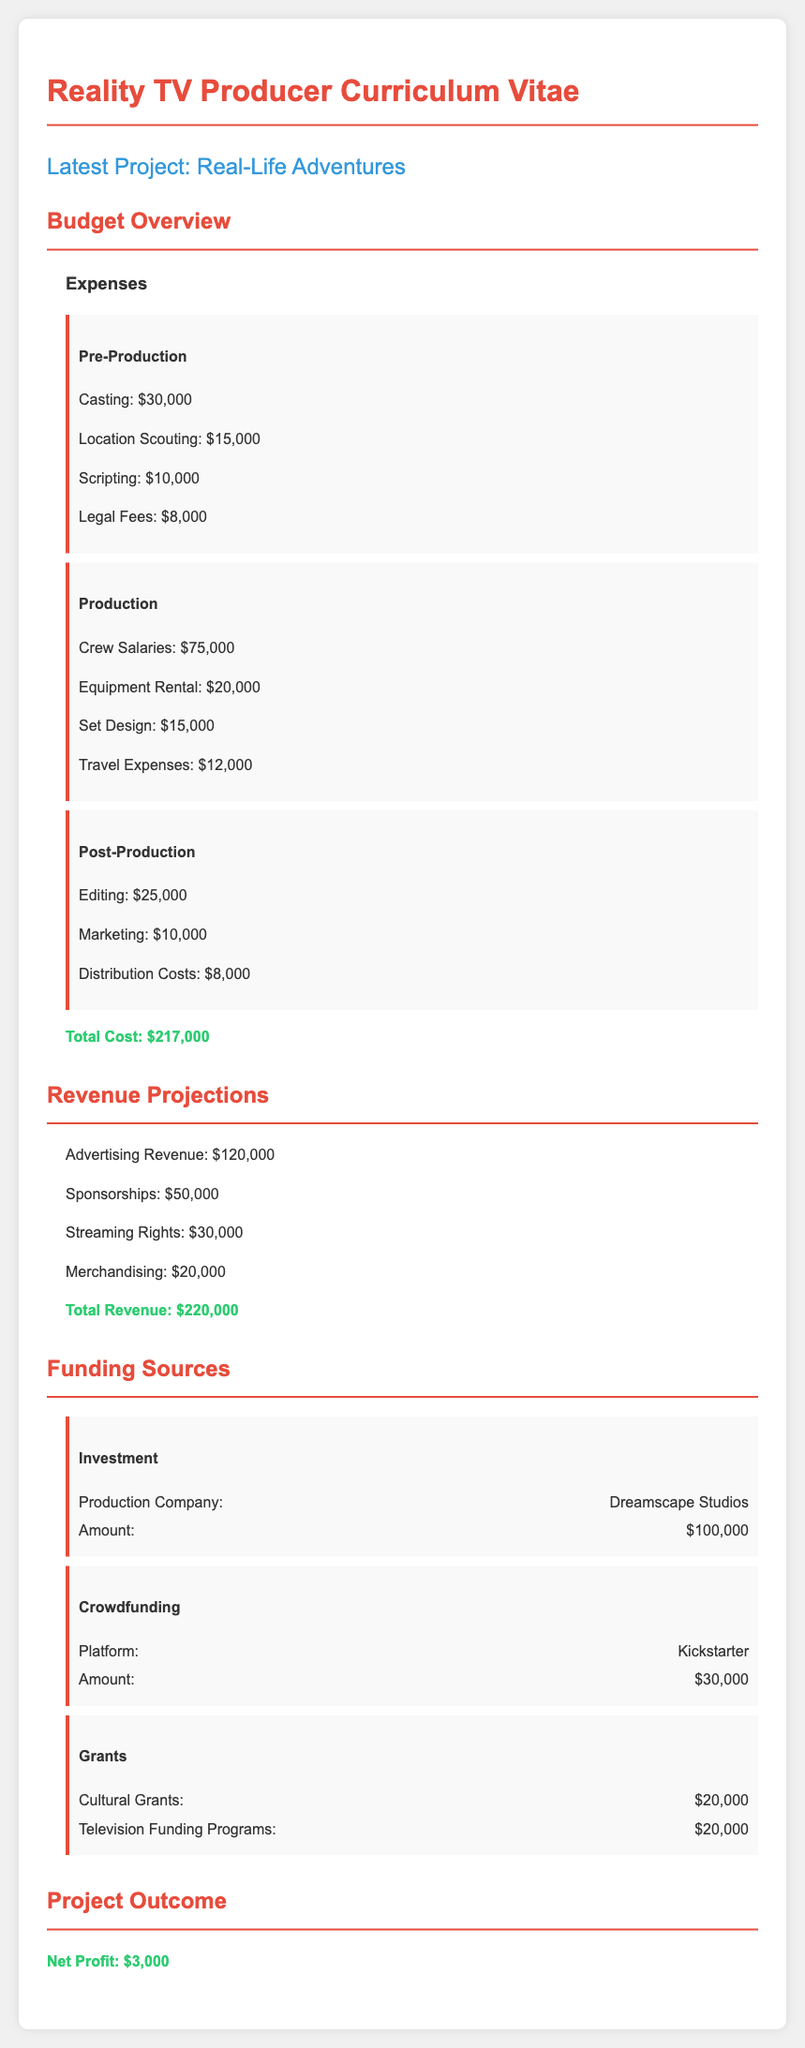What is the total cost? The total cost is calculated by summing all the expenses listed in the document, which totals to $30,000 + $15,000 + $10,000 + $8,000 + $75,000 + $20,000 + $15,000 + $12,000 + $25,000 + $10,000 + $8,000 = $217,000.
Answer: $217,000 What is the sponsorship revenue? The document specifies the sponsorship revenue as one of the sources of revenue, which is $50,000.
Answer: $50,000 How much does the crew salary expense amount to? The crew salary expense is explicitly listed in the expenses section of the document as $75,000.
Answer: $75,000 What are the total revenue projections? The total revenue is calculated by adding all revenue sources mentioned, which includes advertising, sponsorships, streaming rights, and merchandising, amounting to $120,000 + $50,000 + $30,000 + $20,000 = $220,000.
Answer: $220,000 What is the total amount from investment? The investment from the production company is identified in the funding sources as $100,000.
Answer: $100,000 What is the net profit of the project? The net profit is presented as the difference between total revenue and total costs, calculated to be $3,000.
Answer: $3,000 How much was raised through crowdfunding? The document indicates that the crowdfunding platform raised $30,000, which is noted in the funding sources section.
Answer: $30,000 Which platform was used for crowdfunding? The crowdfunding platform mentioned in the document is Kickstarter.
Answer: Kickstarter 